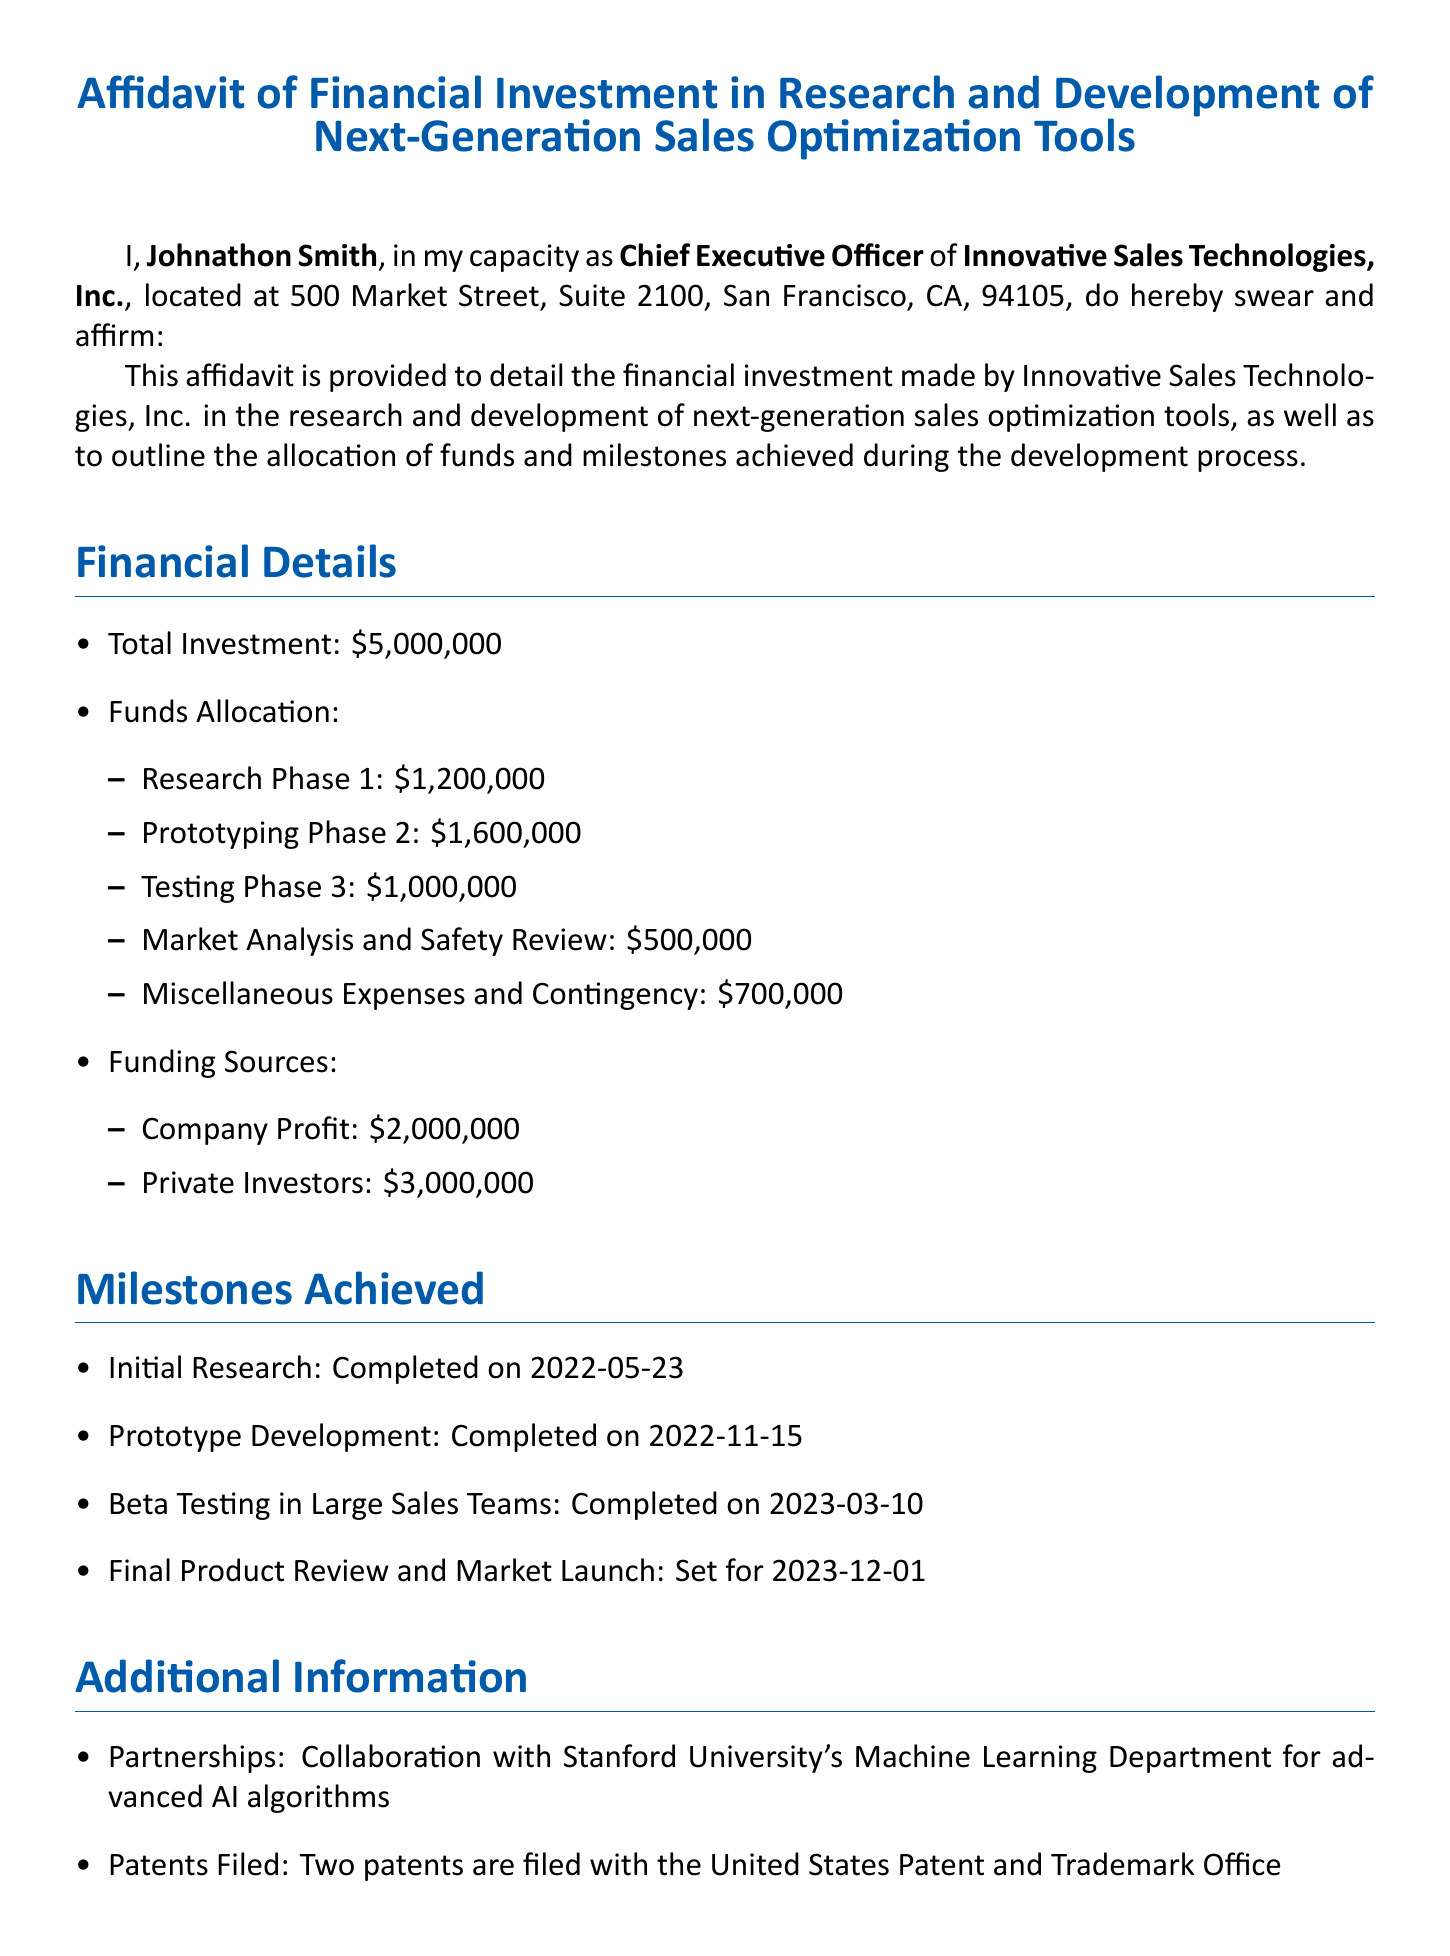what is the total investment made by Innovative Sales Technologies, Inc.? The total investment is stated in the financial details section of the document, which is $5,000,000.
Answer: $5,000,000 who is the Chief Executive Officer of Innovative Sales Technologies, Inc.? The CEO is clearly identified at the beginning of the document.
Answer: Johnathon Smith how much was allocated for the Prototyping Phase? The amount allocated for the Prototyping Phase can be found under the funds allocation section.
Answer: $1,600,000 when was the Initial Research completed? The completion date can be found in the milestones achieved section of the document.
Answer: 2022-05-23 what partnership is mentioned in the affidavit? The document mentions a specific collaboration in the additional information section.
Answer: Stanford University's Machine Learning Department how many patents have been filed according to the document? The number of patents filed is indicated in the additional information section.
Answer: Two what is the estimated market size for the sales optimization tools? The estimated market size is provided in the additional information section.
Answer: $10 billion when is the final product review and market launch scheduled? The date is mentioned in the milestones achieved section.
Answer: 2023-12-01 